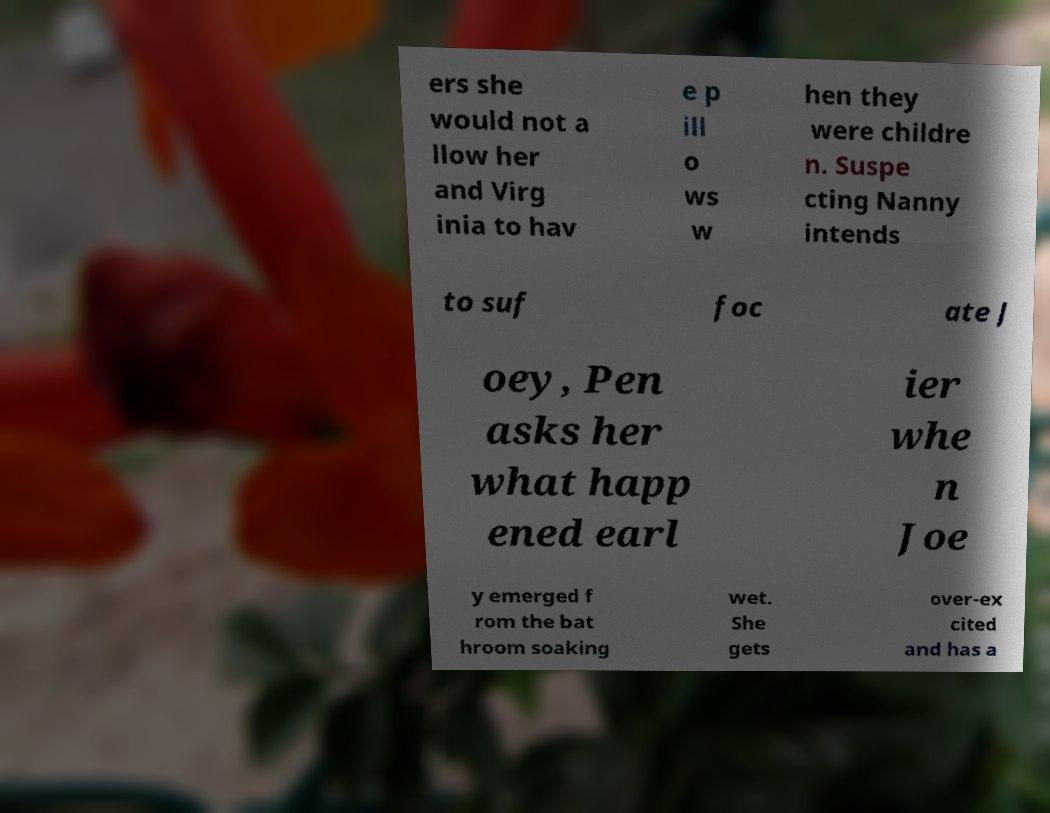For documentation purposes, I need the text within this image transcribed. Could you provide that? ers she would not a llow her and Virg inia to hav e p ill o ws w hen they were childre n. Suspe cting Nanny intends to suf foc ate J oey, Pen asks her what happ ened earl ier whe n Joe y emerged f rom the bat hroom soaking wet. She gets over-ex cited and has a 